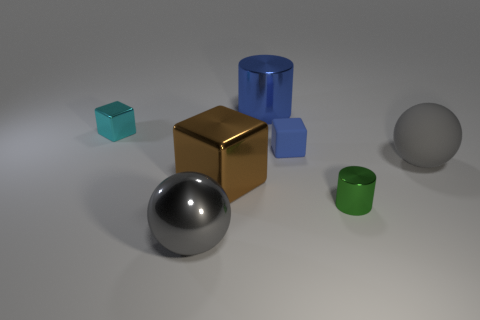Add 2 metallic cubes. How many objects exist? 9 Subtract all cylinders. How many objects are left? 5 Add 4 big metallic blocks. How many big metallic blocks exist? 5 Subtract 0 purple cubes. How many objects are left? 7 Subtract all tiny blue rubber things. Subtract all brown shiny things. How many objects are left? 5 Add 6 small cylinders. How many small cylinders are left? 7 